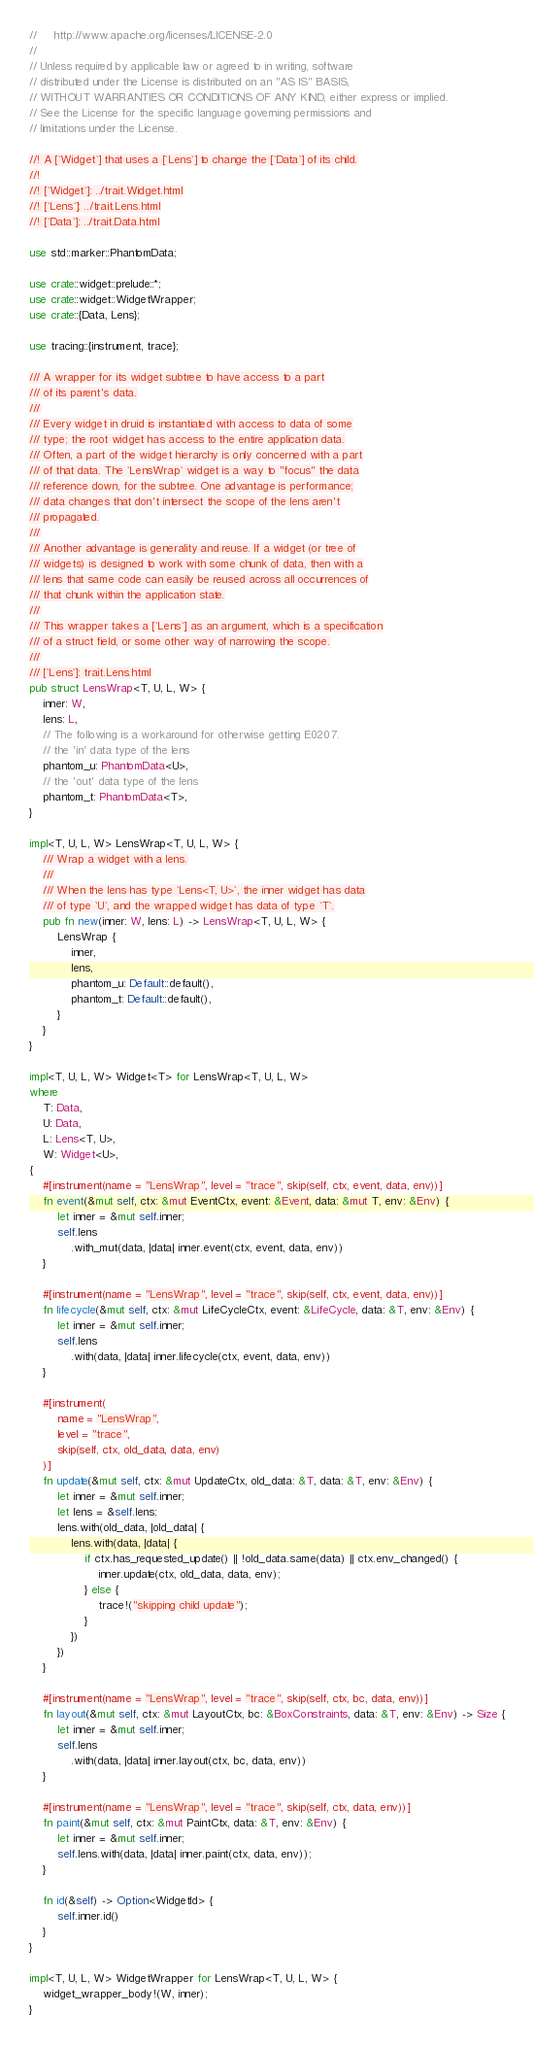Convert code to text. <code><loc_0><loc_0><loc_500><loc_500><_Rust_>//     http://www.apache.org/licenses/LICENSE-2.0
//
// Unless required by applicable law or agreed to in writing, software
// distributed under the License is distributed on an "AS IS" BASIS,
// WITHOUT WARRANTIES OR CONDITIONS OF ANY KIND, either express or implied.
// See the License for the specific language governing permissions and
// limitations under the License.

//! A [`Widget`] that uses a [`Lens`] to change the [`Data`] of its child.
//!
//! [`Widget`]: ../trait.Widget.html
//! [`Lens`]: ../trait.Lens.html
//! [`Data`]: ../trait.Data.html

use std::marker::PhantomData;

use crate::widget::prelude::*;
use crate::widget::WidgetWrapper;
use crate::{Data, Lens};

use tracing::{instrument, trace};

/// A wrapper for its widget subtree to have access to a part
/// of its parent's data.
///
/// Every widget in druid is instantiated with access to data of some
/// type; the root widget has access to the entire application data.
/// Often, a part of the widget hierarchy is only concerned with a part
/// of that data. The `LensWrap` widget is a way to "focus" the data
/// reference down, for the subtree. One advantage is performance;
/// data changes that don't intersect the scope of the lens aren't
/// propagated.
///
/// Another advantage is generality and reuse. If a widget (or tree of
/// widgets) is designed to work with some chunk of data, then with a
/// lens that same code can easily be reused across all occurrences of
/// that chunk within the application state.
///
/// This wrapper takes a [`Lens`] as an argument, which is a specification
/// of a struct field, or some other way of narrowing the scope.
///
/// [`Lens`]: trait.Lens.html
pub struct LensWrap<T, U, L, W> {
    inner: W,
    lens: L,
    // The following is a workaround for otherwise getting E0207.
    // the 'in' data type of the lens
    phantom_u: PhantomData<U>,
    // the 'out' data type of the lens
    phantom_t: PhantomData<T>,
}

impl<T, U, L, W> LensWrap<T, U, L, W> {
    /// Wrap a widget with a lens.
    ///
    /// When the lens has type `Lens<T, U>`, the inner widget has data
    /// of type `U`, and the wrapped widget has data of type `T`.
    pub fn new(inner: W, lens: L) -> LensWrap<T, U, L, W> {
        LensWrap {
            inner,
            lens,
            phantom_u: Default::default(),
            phantom_t: Default::default(),
        }
    }
}

impl<T, U, L, W> Widget<T> for LensWrap<T, U, L, W>
where
    T: Data,
    U: Data,
    L: Lens<T, U>,
    W: Widget<U>,
{
    #[instrument(name = "LensWrap", level = "trace", skip(self, ctx, event, data, env))]
    fn event(&mut self, ctx: &mut EventCtx, event: &Event, data: &mut T, env: &Env) {
        let inner = &mut self.inner;
        self.lens
            .with_mut(data, |data| inner.event(ctx, event, data, env))
    }

    #[instrument(name = "LensWrap", level = "trace", skip(self, ctx, event, data, env))]
    fn lifecycle(&mut self, ctx: &mut LifeCycleCtx, event: &LifeCycle, data: &T, env: &Env) {
        let inner = &mut self.inner;
        self.lens
            .with(data, |data| inner.lifecycle(ctx, event, data, env))
    }

    #[instrument(
        name = "LensWrap",
        level = "trace",
        skip(self, ctx, old_data, data, env)
    )]
    fn update(&mut self, ctx: &mut UpdateCtx, old_data: &T, data: &T, env: &Env) {
        let inner = &mut self.inner;
        let lens = &self.lens;
        lens.with(old_data, |old_data| {
            lens.with(data, |data| {
                if ctx.has_requested_update() || !old_data.same(data) || ctx.env_changed() {
                    inner.update(ctx, old_data, data, env);
                } else {
                    trace!("skipping child update");
                }
            })
        })
    }

    #[instrument(name = "LensWrap", level = "trace", skip(self, ctx, bc, data, env))]
    fn layout(&mut self, ctx: &mut LayoutCtx, bc: &BoxConstraints, data: &T, env: &Env) -> Size {
        let inner = &mut self.inner;
        self.lens
            .with(data, |data| inner.layout(ctx, bc, data, env))
    }

    #[instrument(name = "LensWrap", level = "trace", skip(self, ctx, data, env))]
    fn paint(&mut self, ctx: &mut PaintCtx, data: &T, env: &Env) {
        let inner = &mut self.inner;
        self.lens.with(data, |data| inner.paint(ctx, data, env));
    }

    fn id(&self) -> Option<WidgetId> {
        self.inner.id()
    }
}

impl<T, U, L, W> WidgetWrapper for LensWrap<T, U, L, W> {
    widget_wrapper_body!(W, inner);
}
</code> 